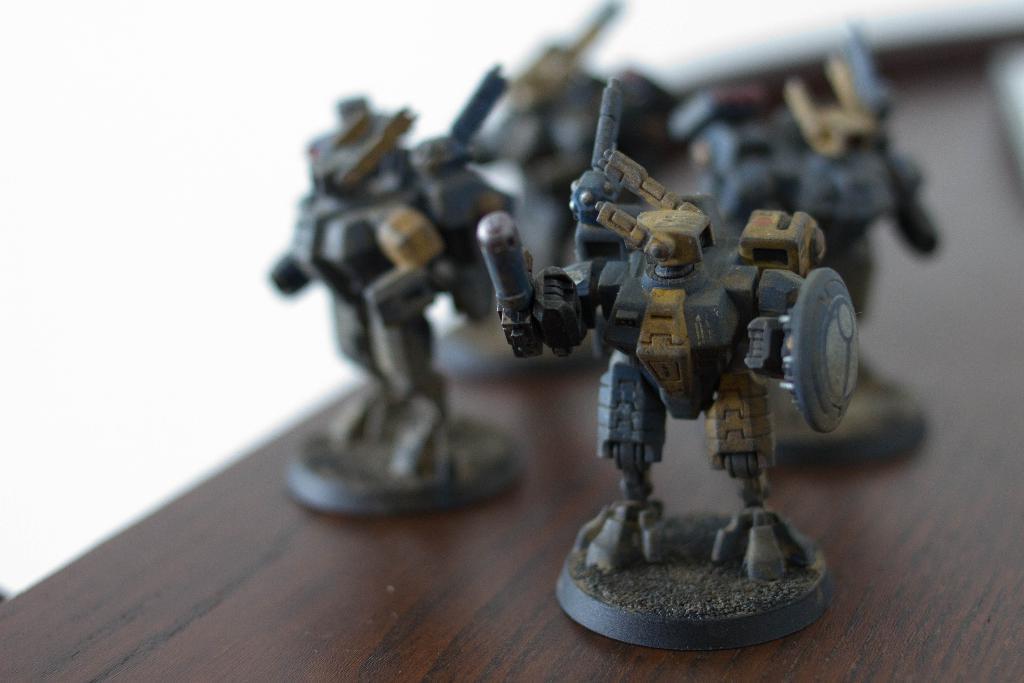Can you describe this image briefly? There are toys arranged on a wooden table. And the background is white in color. 